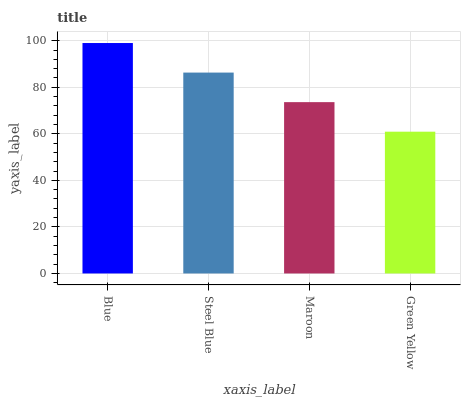Is Green Yellow the minimum?
Answer yes or no. Yes. Is Blue the maximum?
Answer yes or no. Yes. Is Steel Blue the minimum?
Answer yes or no. No. Is Steel Blue the maximum?
Answer yes or no. No. Is Blue greater than Steel Blue?
Answer yes or no. Yes. Is Steel Blue less than Blue?
Answer yes or no. Yes. Is Steel Blue greater than Blue?
Answer yes or no. No. Is Blue less than Steel Blue?
Answer yes or no. No. Is Steel Blue the high median?
Answer yes or no. Yes. Is Maroon the low median?
Answer yes or no. Yes. Is Blue the high median?
Answer yes or no. No. Is Green Yellow the low median?
Answer yes or no. No. 